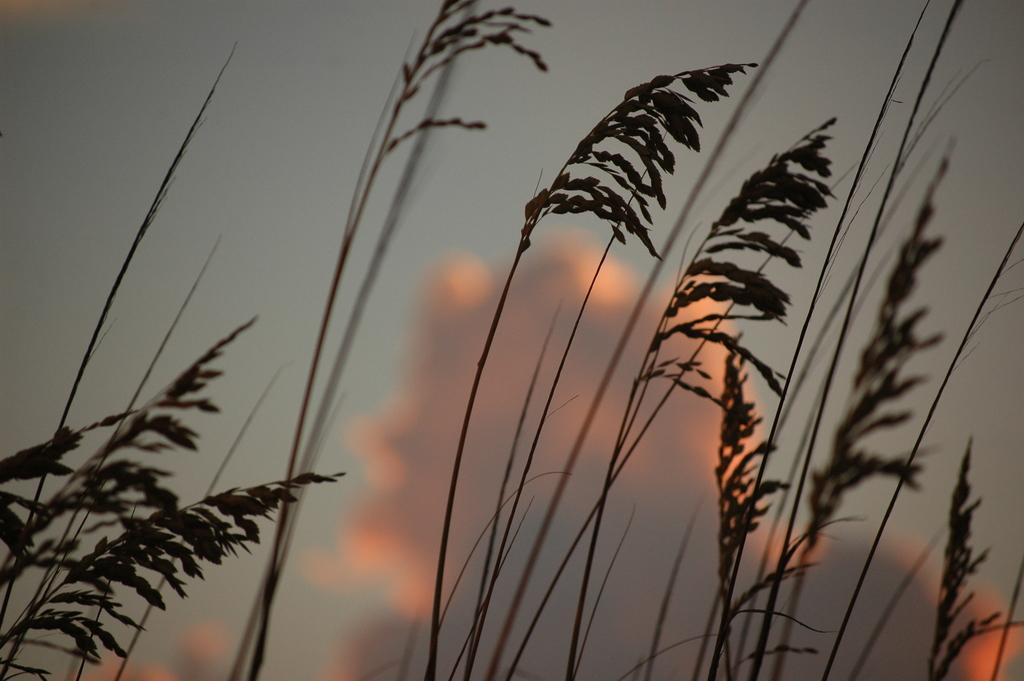What is located in the front of the image? There are plants in the front of the image. What can be seen in the background of the image? There is a cloudy sky in the background of the image. Where is the pin located in the image? There is no pin present in the image. What type of rat can be seen in the image? There are no rats present in the image. 